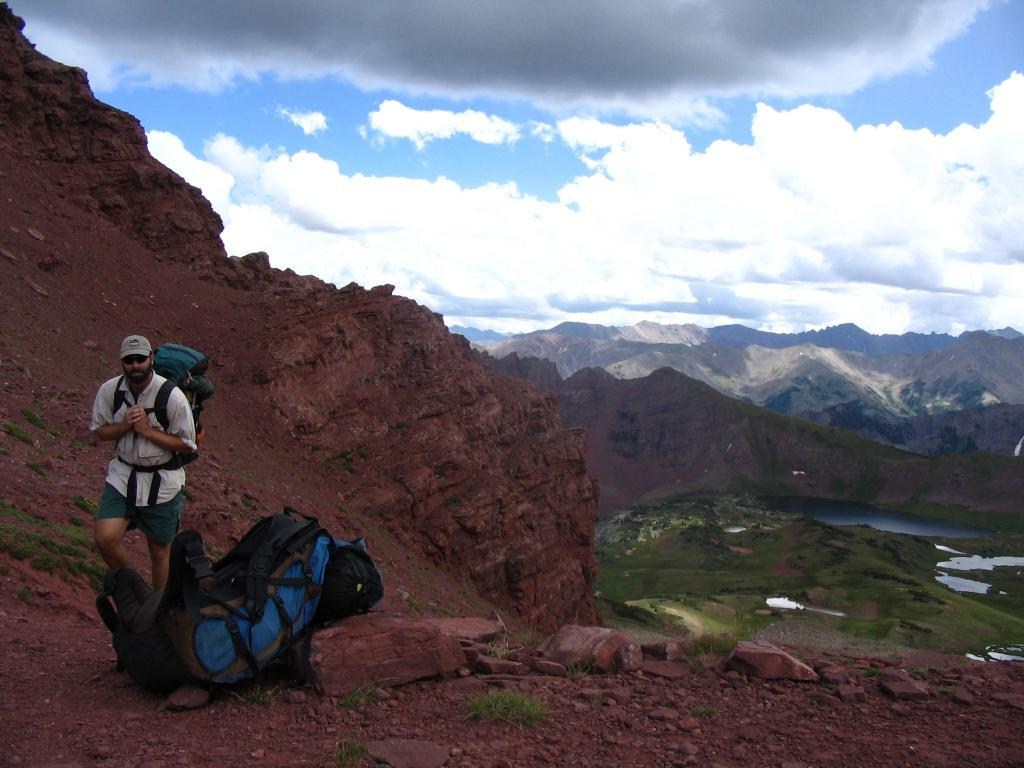What is the man on the left side of the image wearing? The man is wearing a shirt and trousers. What is the man carrying in the image? The man is carrying a bag. What type of headwear is the man wearing? The man is wearing a cap. What can be seen at the bottom of the image? There are bags, grassland, hills, and water visible at the bottom of the image. What is visible in the sky at the top of the image? The sky is visible at the top of the image, and there are clouds visible in the sky. How many blades of grass can be seen in the image? It is not possible to count individual blades of grass in the image, as there are too many to accurately determine a specific number. Are there any women visible in the image? No, there are no women present in the image; only a man is visible. 